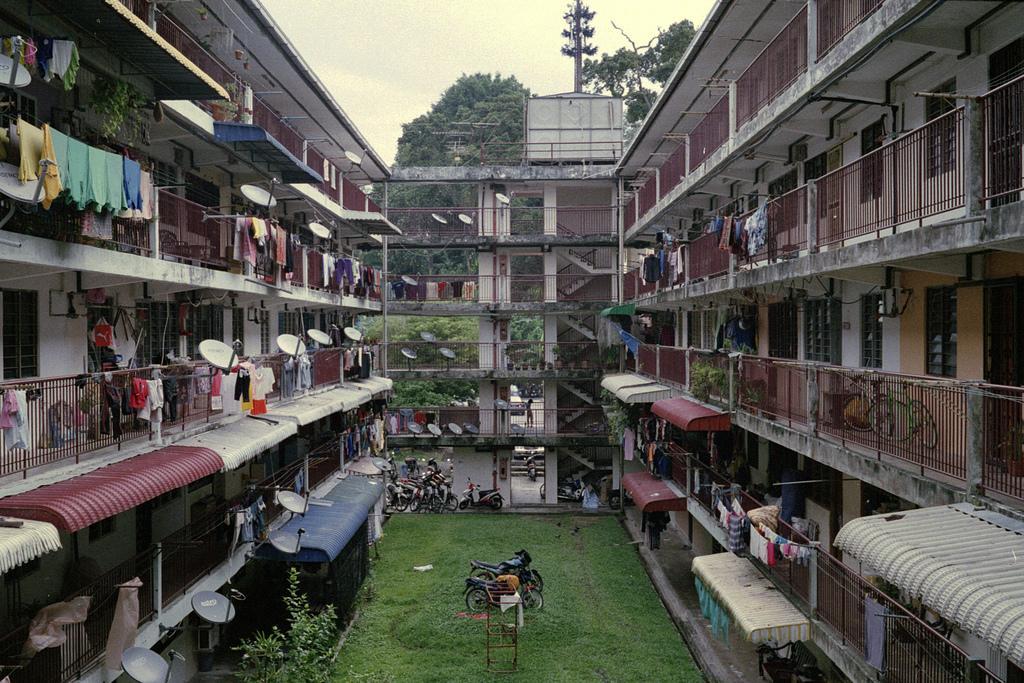Can you describe this image briefly? We can see grass, stand, bikes, vehicles, plants, railings, clothes, dish antenna, building. In the background we can see current pole, trees and sky. 